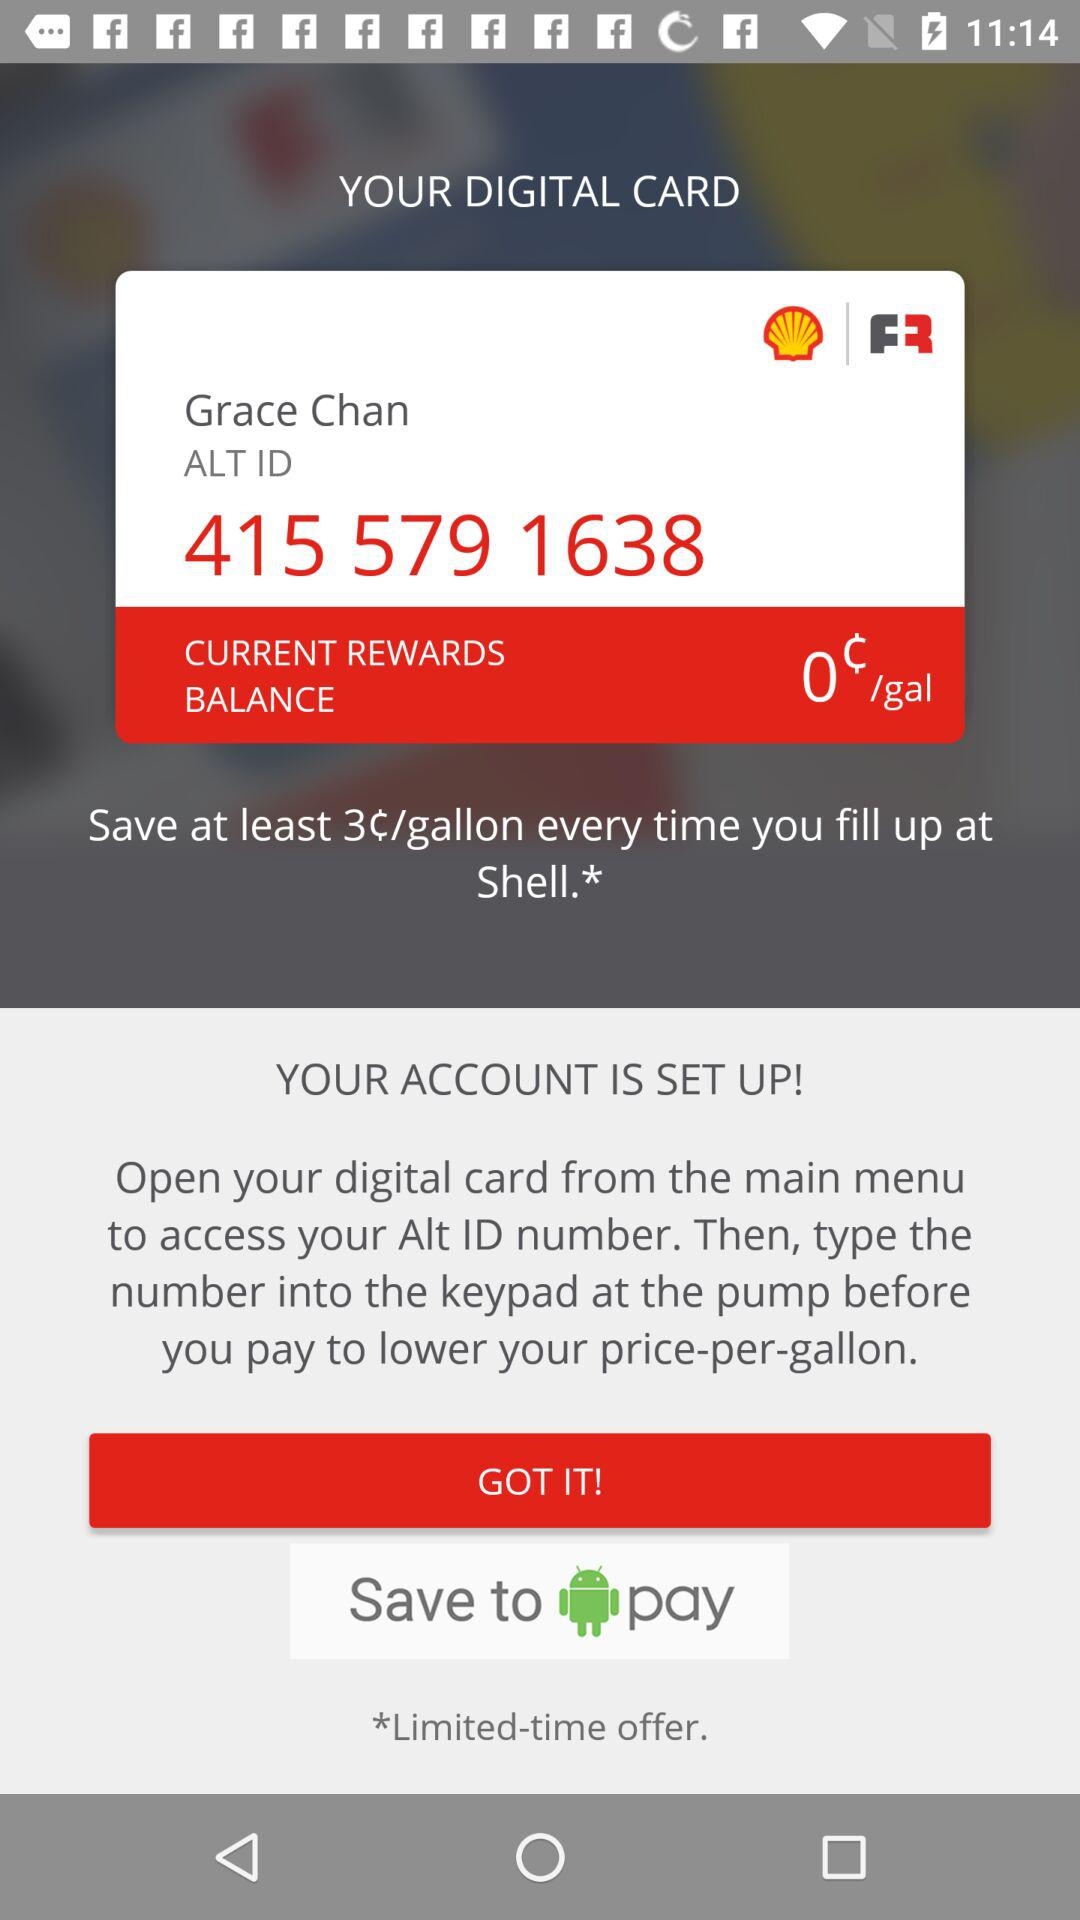What is the current reward balance? The current reward balance is 0 cents per gallon. 